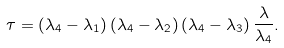<formula> <loc_0><loc_0><loc_500><loc_500>\tau = \left ( \lambda _ { 4 } - \lambda _ { 1 } \right ) \left ( \lambda _ { 4 } - \lambda _ { 2 } \right ) \left ( \lambda _ { 4 } - \lambda _ { 3 } \right ) \frac { \lambda } { \lambda _ { 4 } } .</formula> 